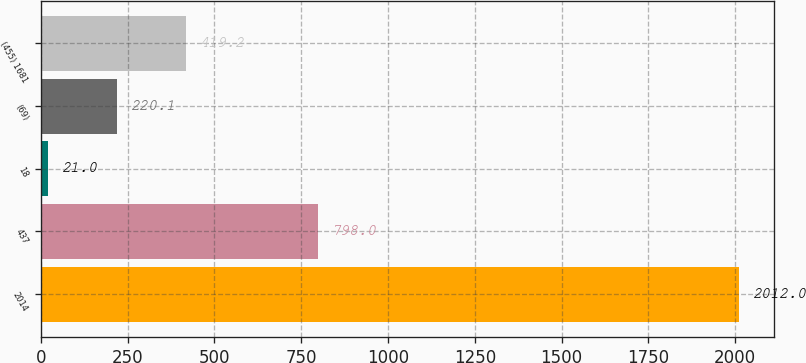Convert chart to OTSL. <chart><loc_0><loc_0><loc_500><loc_500><bar_chart><fcel>2014<fcel>437<fcel>18<fcel>(69)<fcel>(455) 1681<nl><fcel>2012<fcel>798<fcel>21<fcel>220.1<fcel>419.2<nl></chart> 